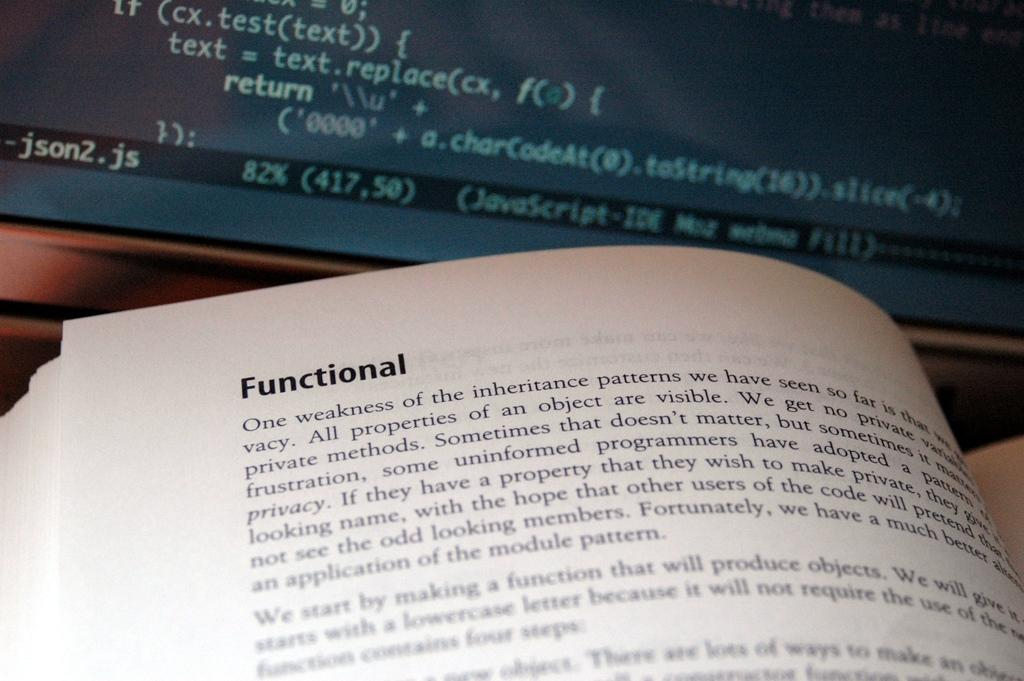<image>
Render a clear and concise summary of the photo. a book that has the word functional at the top 